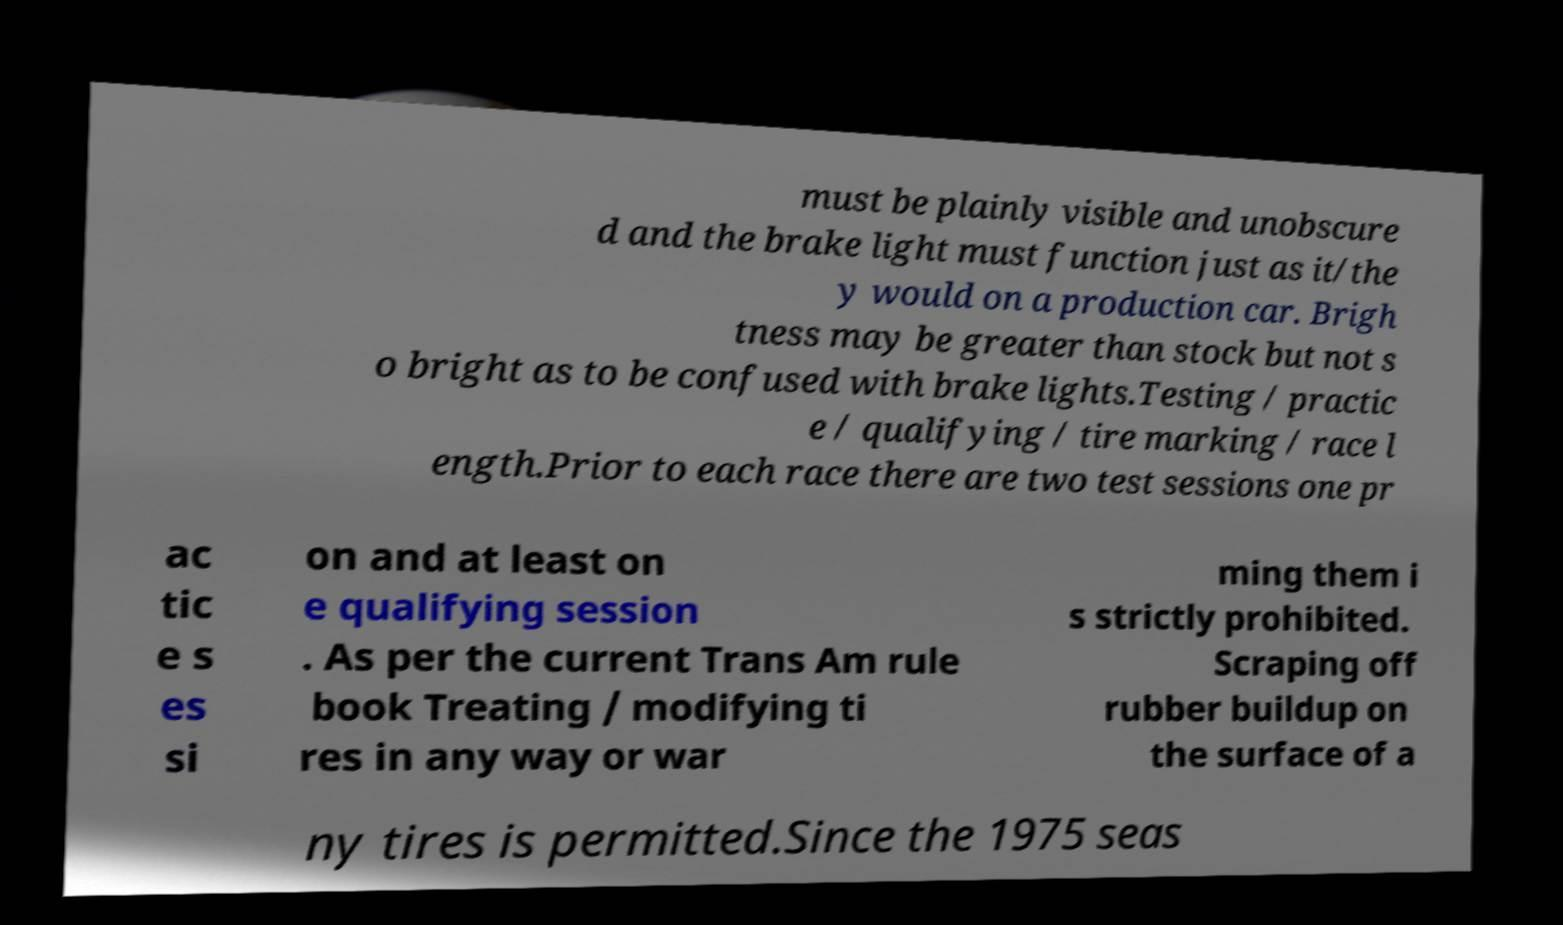Could you extract and type out the text from this image? must be plainly visible and unobscure d and the brake light must function just as it/the y would on a production car. Brigh tness may be greater than stock but not s o bright as to be confused with brake lights.Testing / practic e / qualifying / tire marking / race l ength.Prior to each race there are two test sessions one pr ac tic e s es si on and at least on e qualifying session . As per the current Trans Am rule book Treating / modifying ti res in any way or war ming them i s strictly prohibited. Scraping off rubber buildup on the surface of a ny tires is permitted.Since the 1975 seas 